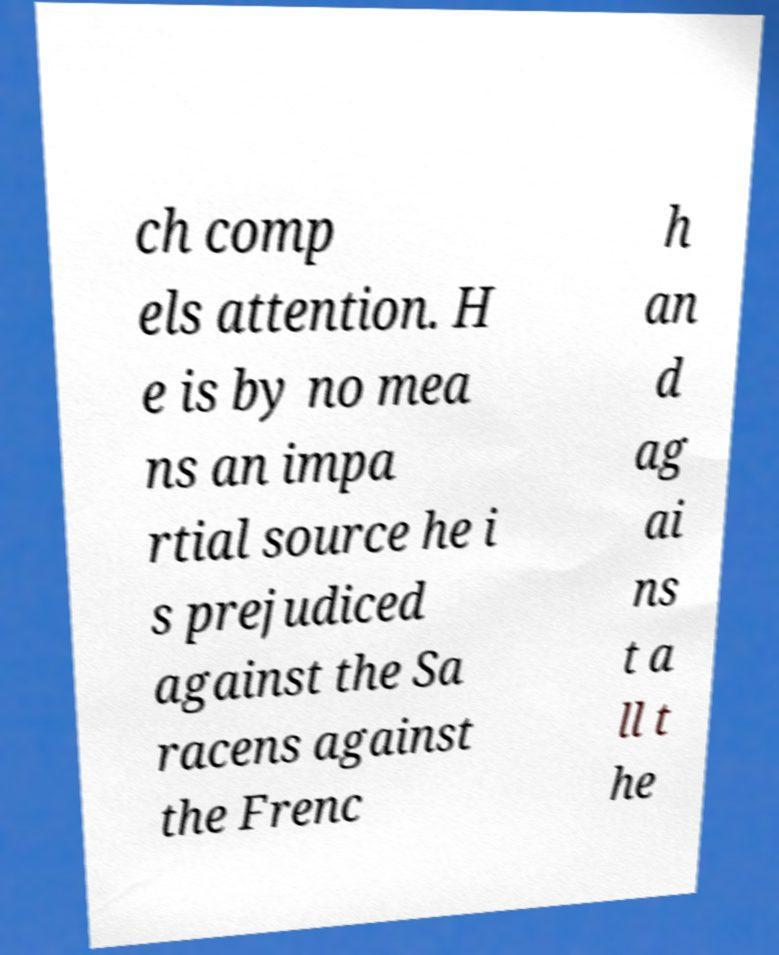Please identify and transcribe the text found in this image. ch comp els attention. H e is by no mea ns an impa rtial source he i s prejudiced against the Sa racens against the Frenc h an d ag ai ns t a ll t he 